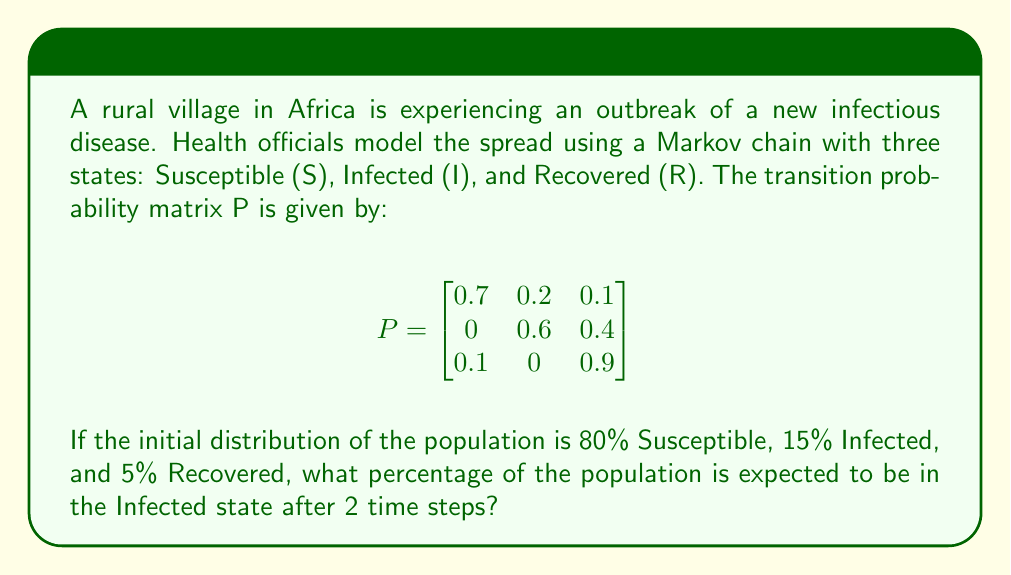What is the answer to this math problem? Let's approach this step-by-step:

1) First, we need to represent the initial distribution as a row vector:

   $\pi_0 = [0.8 \quad 0.15 \quad 0.05]$

2) To find the distribution after 2 time steps, we need to multiply this initial distribution by the transition matrix P twice:

   $\pi_2 = \pi_0 \cdot P^2$

3) Let's calculate $P^2$:

   $$P^2 = \begin{bmatrix}
   0.7 & 0.2 & 0.1 \\
   0 & 0.6 & 0.4 \\
   0.1 & 0 & 0.9
   \end{bmatrix} \cdot 
   \begin{bmatrix}
   0.7 & 0.2 & 0.1 \\
   0 & 0.6 & 0.4 \\
   0.1 & 0 & 0.9
   \end{bmatrix}$$

   $$P^2 = \begin{bmatrix}
   0.51 & 0.26 & 0.23 \\
   0.04 & 0.36 & 0.60 \\
   0.16 & 0.18 & 0.66
   \end{bmatrix}$$

4) Now, let's multiply $\pi_0$ by $P^2$:

   $\pi_2 = [0.8 \quad 0.15 \quad 0.05] \cdot 
   \begin{bmatrix}
   0.51 & 0.26 & 0.23 \\
   0.04 & 0.36 & 0.60 \\
   0.16 & 0.18 & 0.66
   \end{bmatrix}$

5) Performing the matrix multiplication:

   $\pi_2 = [0.414 \quad 0.274 \quad 0.312]$

6) The second element of this vector represents the proportion in the Infected state after 2 time steps.

7) Converting to a percentage: $0.274 \times 100\% = 27.4\%$
Answer: 27.4% 